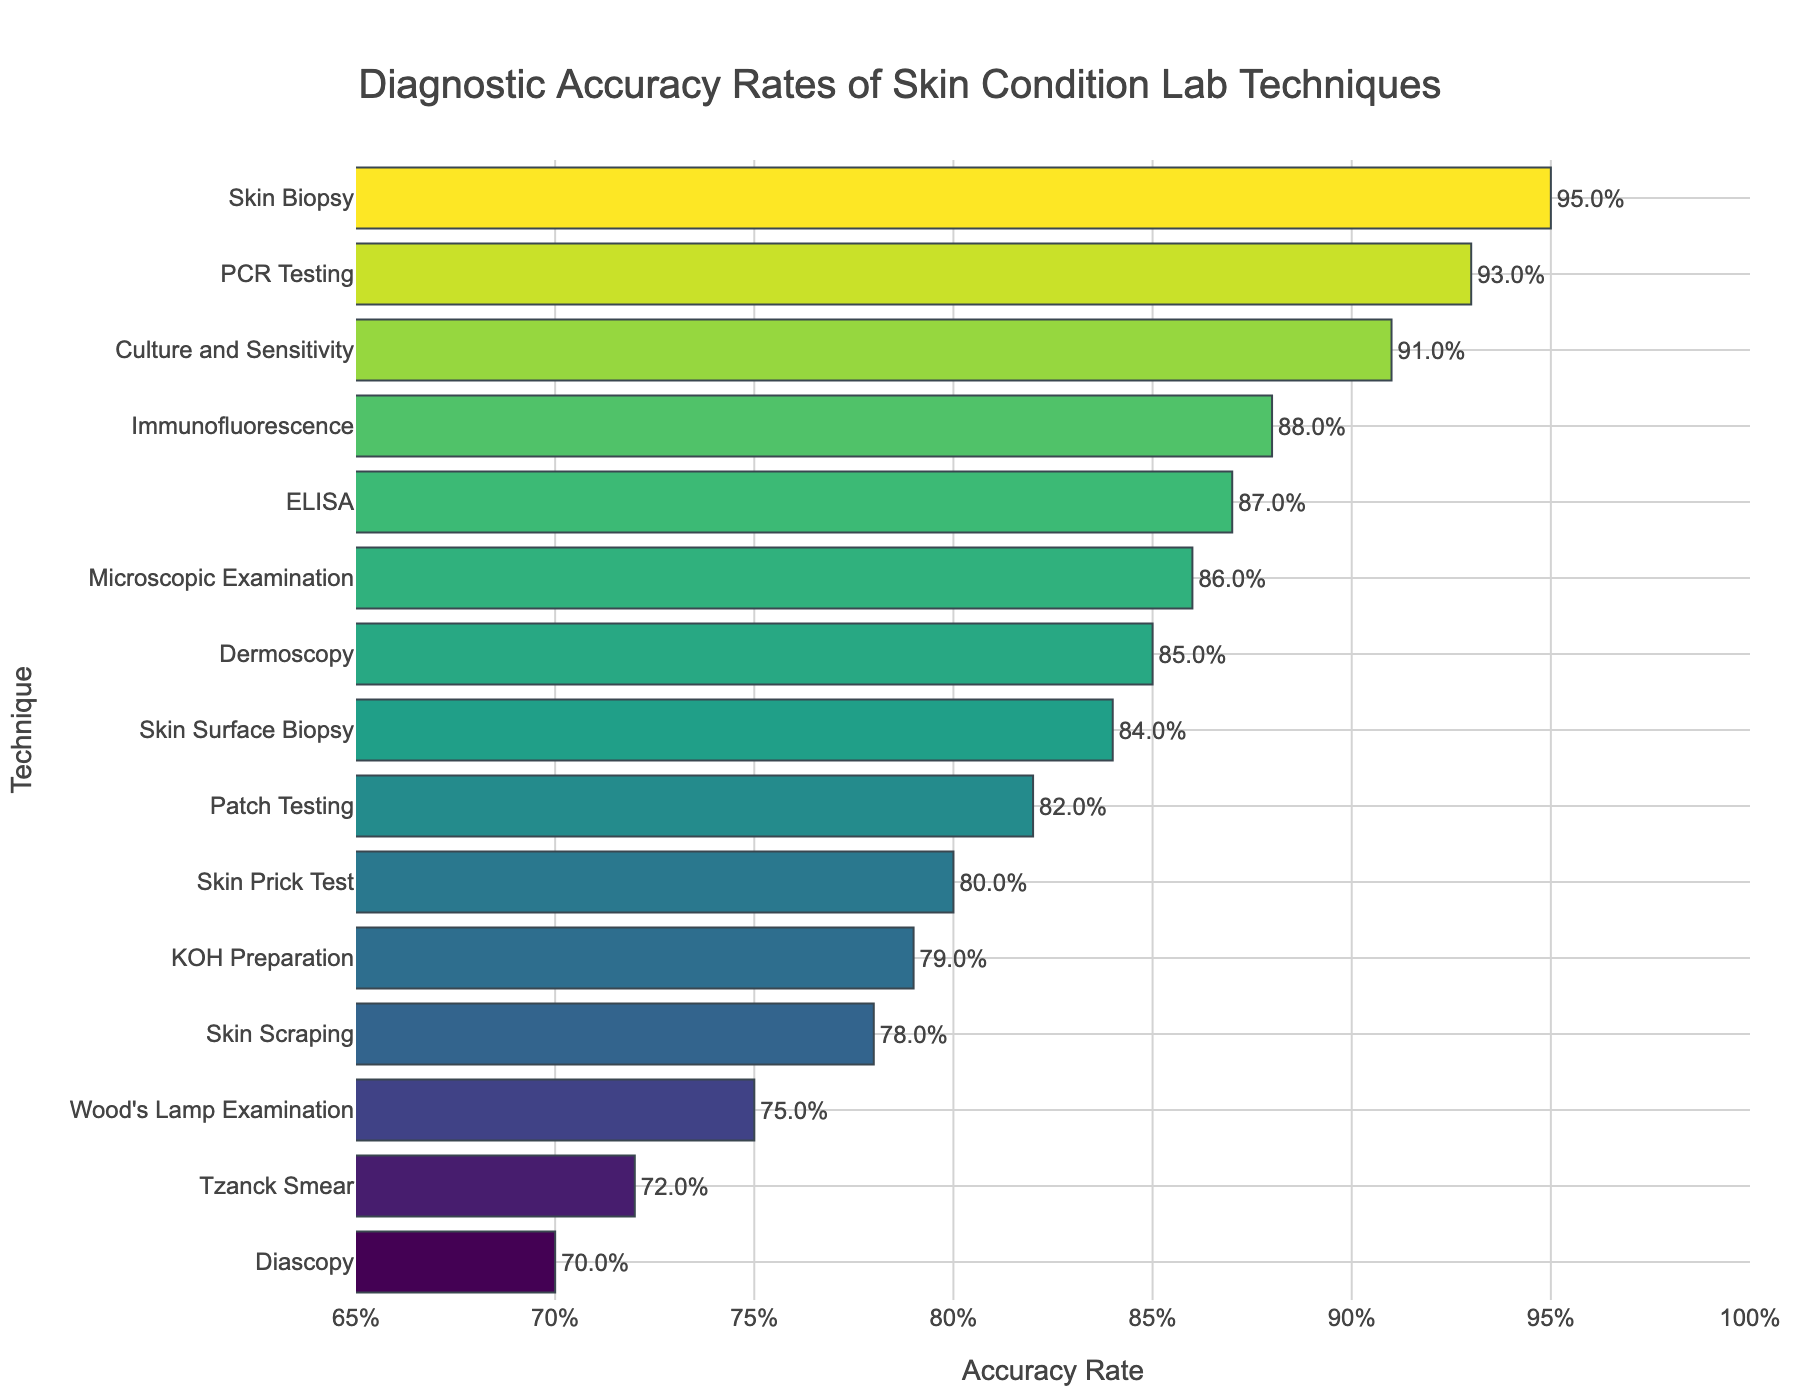What's the technique with the highest diagnostic accuracy rate? The figure shows the accuracy rates in descending order, with the highest rate shown at the top. The technique with the highest bar on the far right is "Skin Biopsy".
Answer: Skin Biopsy Which technique has a lower accuracy rate: KOH Preparation or Skin Scraping? Comparing the bars for "KOH Preparation" and "Skin Scraping," the bar for "Skin Scraping" is shorter, indicating a lower accuracy rate.
Answer: Skin Scraping What's the difference in accuracy rate between PCR Testing and Patch Testing? From the figure, the accuracy rate for PCR Testing is 0.93, and for Patch Testing, it is 0.82. The difference is 0.93 - 0.82 = 0.11.
Answer: 0.11 Which technique is closest in accuracy to Dermoscopy? Dermoscopy has an accuracy rate of 0.85. The bars close to this value are "Skin Surface Biopsy" at 0.84 and "Microscopic Examination" at 0.86.
Answer: Skin Surface Biopsy List the techniques with an accuracy rate equal to or greater than 0.90? Techniques with bars extending to 0.90 or more include "Skin Biopsy" (0.95), "PCR Testing" (0.93), and "Culture and Sensitivity" (0.91).
Answer: Skin Biopsy, PCR Testing, Culture and Sensitivity Which technique has the lowest diagnostic accuracy rate, and what is it? The shortest bar on the far left belongs to "Diascopy," indicating it has the lowest diagnostic accuracy rate with a value of 0.70.
Answer: Diascopy, 0.70 What is the average accuracy rate of Dermoscopy, Immunofluorescence, and ELISA? The accuracy rates are 0.85 for Dermoscopy, 0.88 for Immunofluorescence, and 0.87 for ELISA. Their average is (0.85 + 0.88 + 0.87)/3 = 0.86.
Answer: 0.86 How much higher is the accuracy rate of Culture and Sensitivity compared to Wood's Lamp Examination? Culture and Sensitivity has an accuracy rate of 0.91, and Wood's Lamp Examination has 0.75. The difference is 0.91 - 0.75 = 0.16.
Answer: 0.16 Which two techniques have an accuracy rate difference closest to 0.01? By checking the adjacent bars, "Skin Surface Biopsy" (0.84) and "ELISA" (0.87) have a difference of 0.87 - 0.84 = 0.03, and "Immunofluorescence" (0.88) and "Microscopic Examination" (0.86) have a difference of 0.88 - 0.86 = 0.02. The closest difference is 0.02.
Answer: Immunofluorescence, Microscopic Examination Rank the following techniques by their accuracy rates: Patch Testing, KOH Preparation, Skin Prick Test, Tzanck Smear. Patch Testing has 0.82, KOH Preparation has 0.79, Skin Prick Test has 0.80, and Tzanck Smear has 0.72. Ranking from highest to lowest: Patch Testing, Skin Prick Test, KOH Preparation, Tzanck Smear.
Answer: Patch Testing, Skin Prick Test, KOH Preparation, Tzanck Smear 